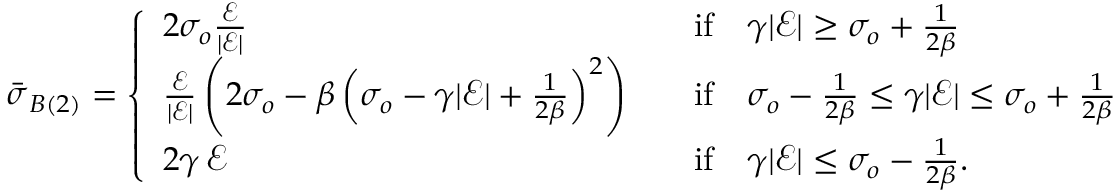<formula> <loc_0><loc_0><loc_500><loc_500>\begin{array} { r } { \bar { \sigma } _ { B ( 2 ) } = \left \{ \begin{array} { l l } { 2 \sigma _ { o } \frac { \mathcal { E } } { | \mathcal { E } | } } & { \quad i f \quad \gamma | \mathcal { E } | \geq \sigma _ { o } + \frac { 1 } { 2 \beta } } \\ { \frac { \mathcal { E } } { | \mathcal { E } | } \left ( 2 \sigma _ { o } - \beta \left ( \sigma _ { o } - \gamma | \mathcal { E } | + \frac { 1 } { 2 \beta } \right ) ^ { 2 } \right ) } & { \quad i f \quad \sigma _ { o } - \frac { 1 } { 2 \beta } \leq \gamma | \mathcal { E } | \leq \sigma _ { o } + \frac { 1 } { 2 \beta } } \\ { 2 \gamma \, \mathcal { E } } & { \quad i f \quad \gamma | \mathcal { E } | \leq \sigma _ { o } - \frac { 1 } { 2 \beta } . } \end{array} } \end{array}</formula> 